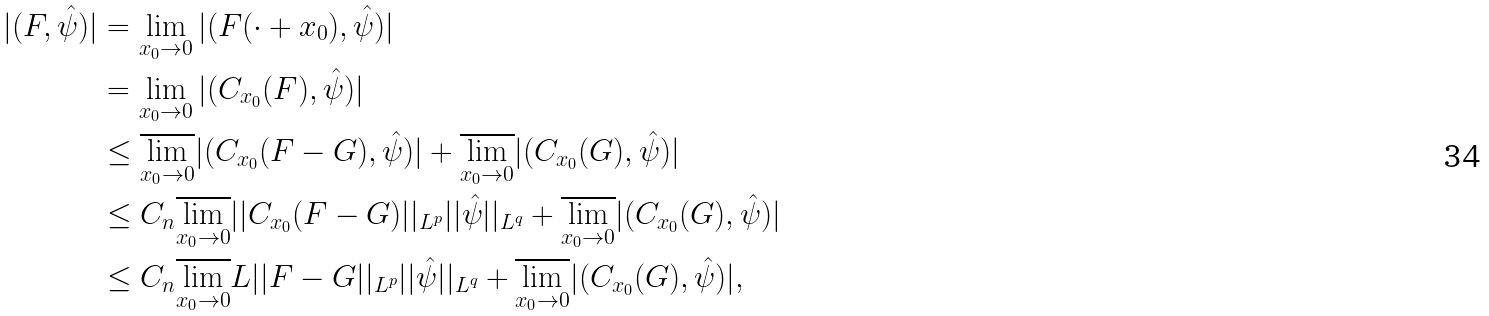Convert formula to latex. <formula><loc_0><loc_0><loc_500><loc_500>| ( F , \hat { \psi } ) | & = \lim _ { x _ { 0 } \to 0 } | ( F ( \cdot + x _ { 0 } ) , \hat { \psi } ) | \\ & = \lim _ { x _ { 0 } \to 0 } | ( C _ { x _ { 0 } } ( F ) , \hat { \psi } ) | \\ & \leq \overline { \lim _ { x _ { 0 } \to 0 } } | ( C _ { x _ { 0 } } ( F - G ) , \hat { \psi } ) | + \overline { \lim _ { x _ { 0 } \to 0 } } | ( C _ { x _ { 0 } } ( G ) , \hat { \psi } ) | \\ & \leq C _ { n } \overline { \lim _ { x _ { 0 } \to 0 } } | | C _ { x _ { 0 } } ( F - G ) | | _ { L ^ { p } } | | \hat { \psi } | | _ { L ^ { q } } + \overline { \lim _ { x _ { 0 } \to 0 } } | ( C _ { x _ { 0 } } ( G ) , \hat { \psi } ) | \\ & \leq C _ { n } \overline { \lim _ { x _ { 0 } \to 0 } } L | | F - G | | _ { L ^ { p } } | | \hat { \psi } | | _ { L ^ { q } } + \overline { \lim _ { x _ { 0 } \to 0 } } | ( C _ { x _ { 0 } } ( G ) , \hat { \psi } ) | ,</formula> 